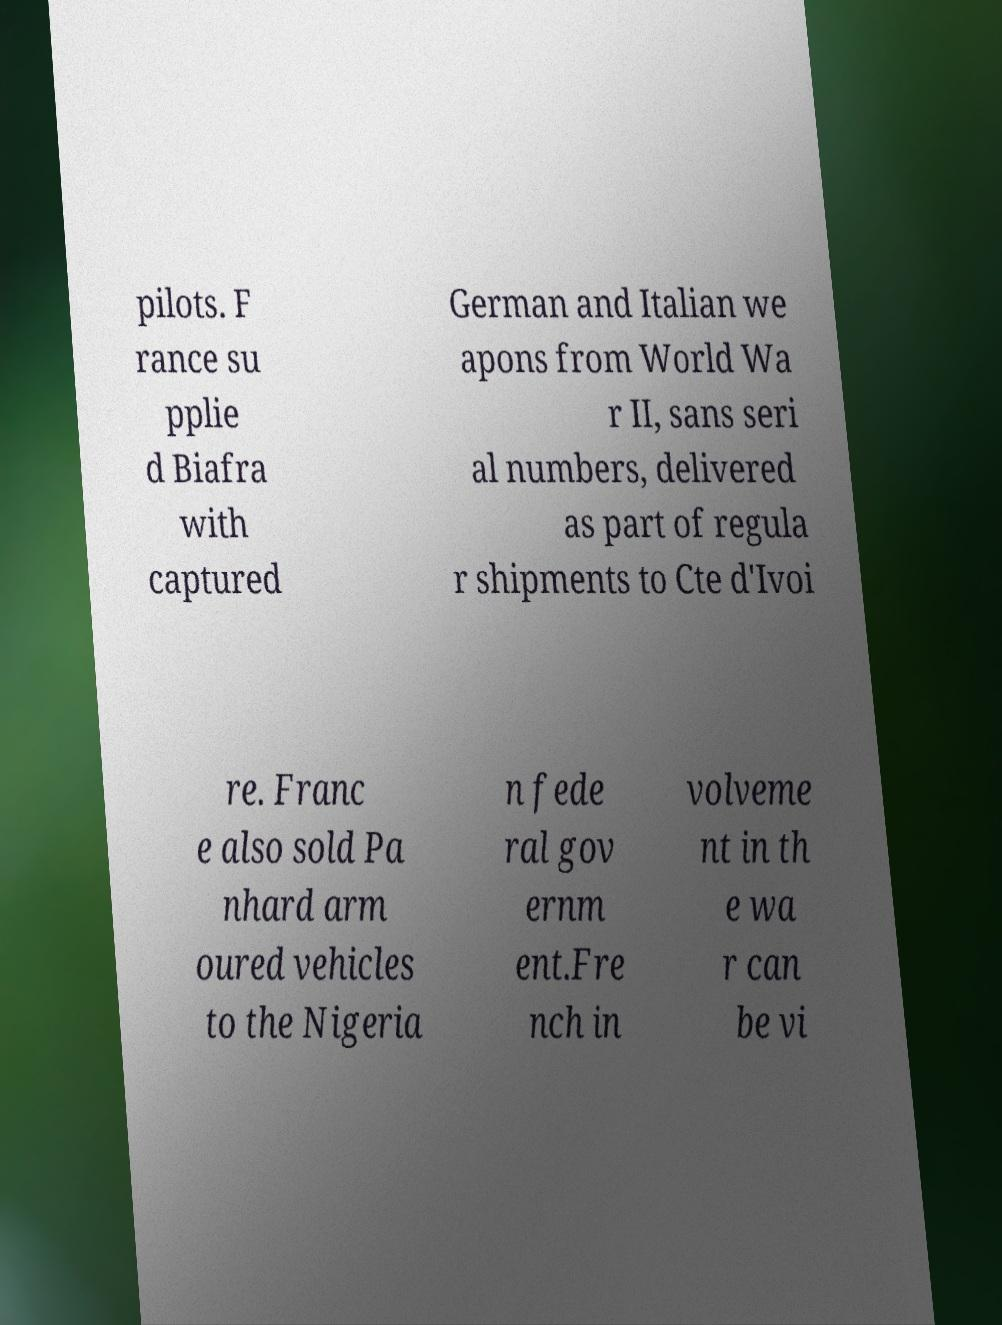What messages or text are displayed in this image? I need them in a readable, typed format. pilots. F rance su pplie d Biafra with captured German and Italian we apons from World Wa r II, sans seri al numbers, delivered as part of regula r shipments to Cte d'Ivoi re. Franc e also sold Pa nhard arm oured vehicles to the Nigeria n fede ral gov ernm ent.Fre nch in volveme nt in th e wa r can be vi 